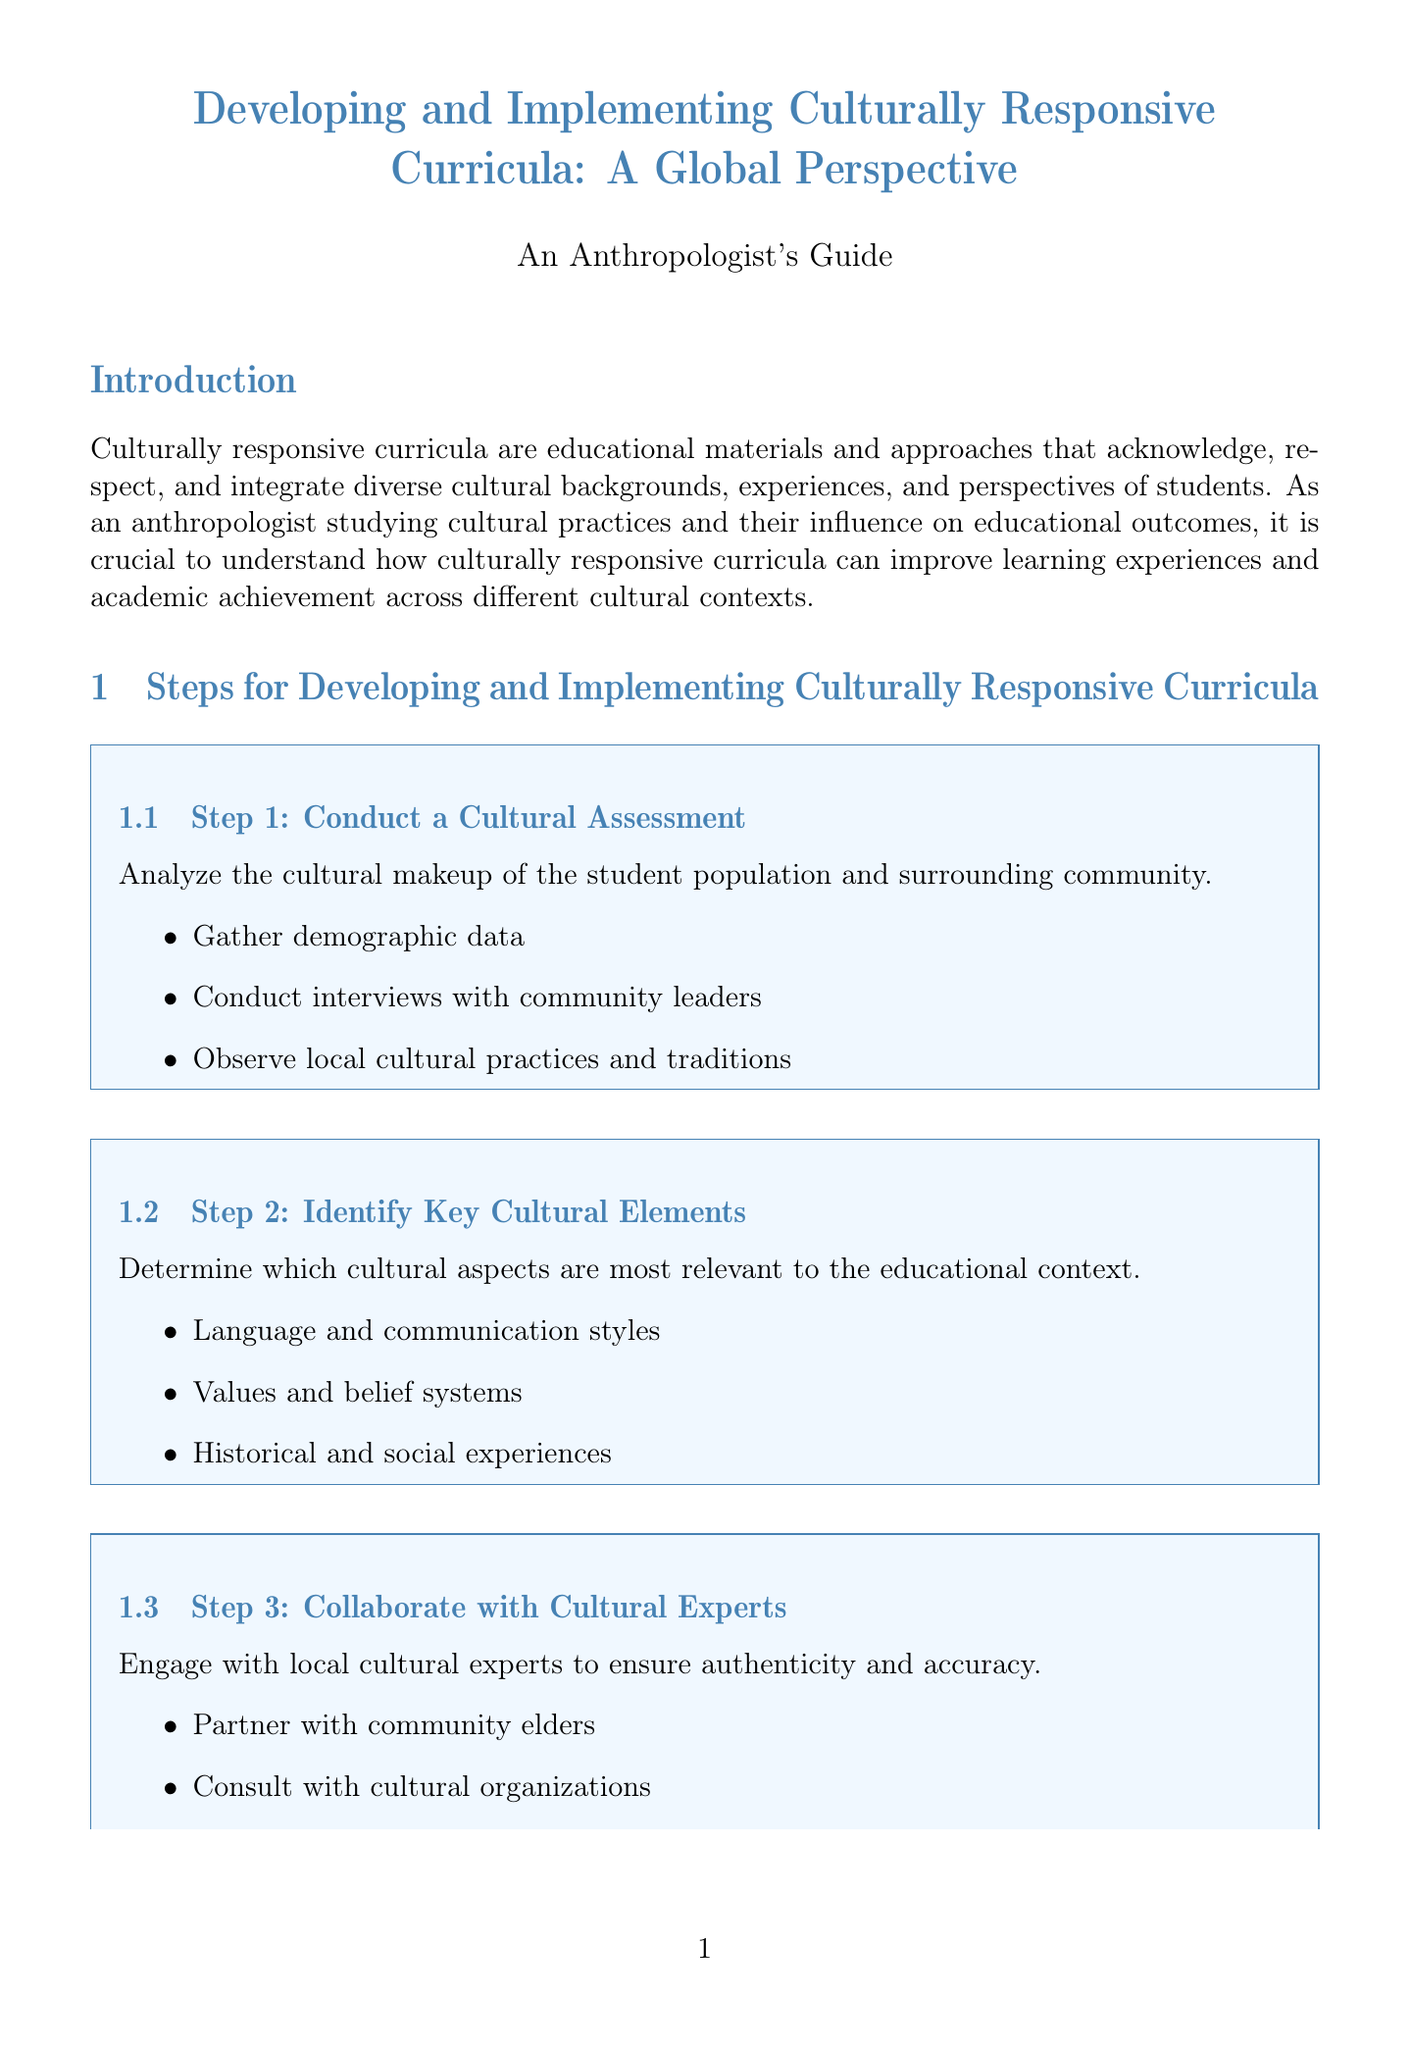What are culturally responsive curricula? Culturally responsive curricula are educational materials and approaches that acknowledge, respect, and integrate diverse cultural backgrounds, experiences, and perspectives of students.
Answer: Educational materials and approaches that acknowledge diverse cultural backgrounds What is the first step in developing culturally responsive curricula? The document lists the first step as "Conduct a Cultural Assessment."
Answer: Conduct a Cultural Assessment What is one outcome of the Maori-Centered Curriculum in New Zealand? The document states that one outcome is "Improved academic performance among Maori students."
Answer: Improved academic performance among Maori students How many steps are outlined for developing culturally responsive curricula? The document lists a total of eight steps to follow.
Answer: Eight Which cultural policy is part of the Multicultural Education in Singapore? The bilingual education policy is mentioned as a key element.
Answer: Bilingual education policy What type of teaching strategies are encouraged in the document? The document suggests "designing inclusive teaching strategies" that accommodate various learning styles and cultural norms.
Answer: Inclusive teaching strategies What case study highlights the integration of Indigenous perspectives in Australia? The case study titled "Indigenous Knowledge Integration in Australian Curriculum" highlights this aspect.
Answer: Indigenous Knowledge Integration in Australian Curriculum What should be implemented first in the curriculum roll-out process? According to the document, it suggests starting with pilot programs.
Answer: Pilot programs 